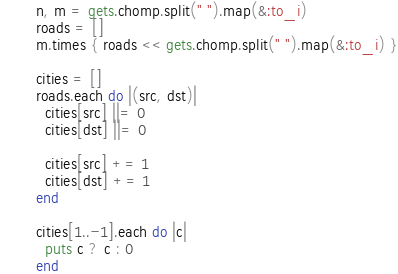Convert code to text. <code><loc_0><loc_0><loc_500><loc_500><_Ruby_>n, m = gets.chomp.split(" ").map(&:to_i)
roads = []
m.times { roads << gets.chomp.split(" ").map(&:to_i) }

cities = []
roads.each do |(src, dst)|
  cities[src] ||= 0
  cities[dst] ||= 0

  cities[src] += 1
  cities[dst] += 1
end

cities[1..-1].each do |c|
  puts c ? c : 0
end
</code> 